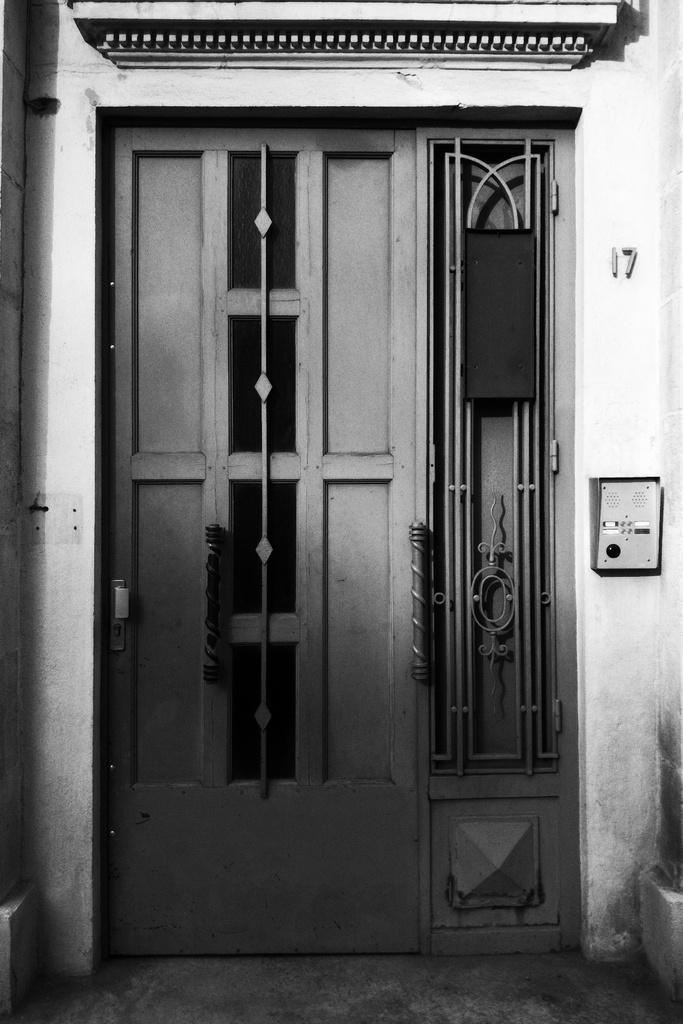What type of opening can be seen in the image? There is a door in the image. What other type of opening is present in the image? There is a window in the image. What can be found on the wall in the image? There is a switchboard on the wall in the image. Can you see any rabbits hopping through the sleet in the image? There are no rabbits or sleet present in the image; it only features a door, a window, and a switchboard on the wall. 